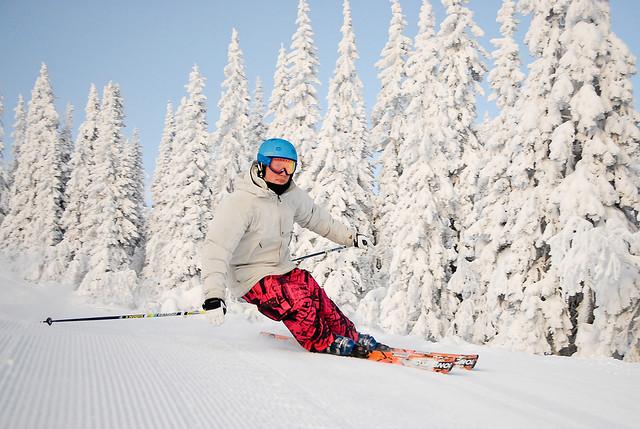What is this person doing?
Short answer required. Skiing. What color is the helmet?
Concise answer only. Blue. What is on all the trees?
Quick response, please. Snow. What do the men have on their backs?
Give a very brief answer. Coats. 